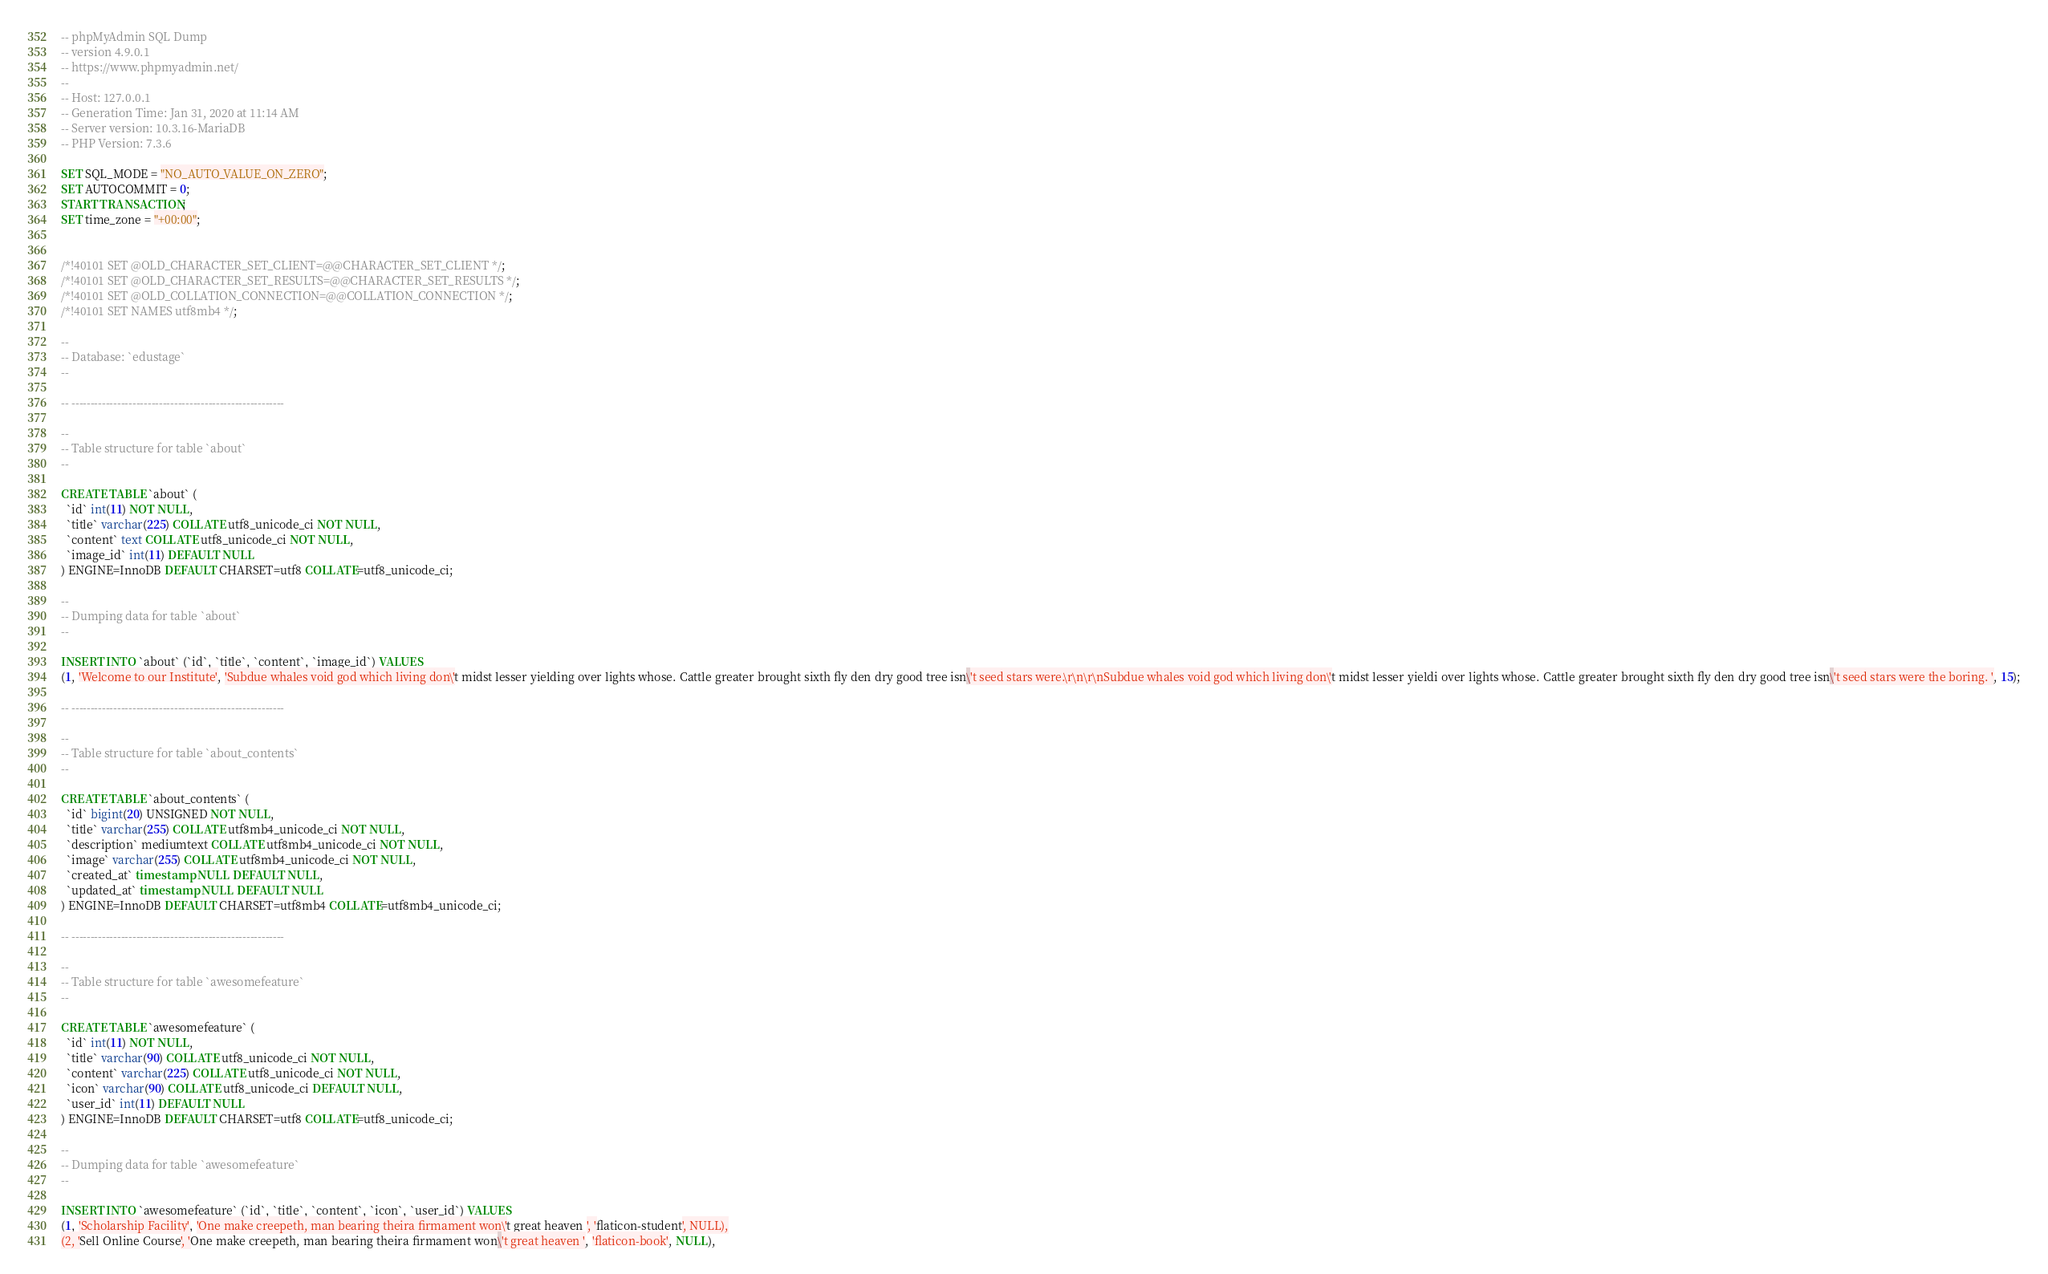<code> <loc_0><loc_0><loc_500><loc_500><_SQL_>-- phpMyAdmin SQL Dump
-- version 4.9.0.1
-- https://www.phpmyadmin.net/
--
-- Host: 127.0.0.1
-- Generation Time: Jan 31, 2020 at 11:14 AM
-- Server version: 10.3.16-MariaDB
-- PHP Version: 7.3.6

SET SQL_MODE = "NO_AUTO_VALUE_ON_ZERO";
SET AUTOCOMMIT = 0;
START TRANSACTION;
SET time_zone = "+00:00";


/*!40101 SET @OLD_CHARACTER_SET_CLIENT=@@CHARACTER_SET_CLIENT */;
/*!40101 SET @OLD_CHARACTER_SET_RESULTS=@@CHARACTER_SET_RESULTS */;
/*!40101 SET @OLD_COLLATION_CONNECTION=@@COLLATION_CONNECTION */;
/*!40101 SET NAMES utf8mb4 */;

--
-- Database: `edustage`
--

-- --------------------------------------------------------

--
-- Table structure for table `about`
--

CREATE TABLE `about` (
  `id` int(11) NOT NULL,
  `title` varchar(225) COLLATE utf8_unicode_ci NOT NULL,
  `content` text COLLATE utf8_unicode_ci NOT NULL,
  `image_id` int(11) DEFAULT NULL
) ENGINE=InnoDB DEFAULT CHARSET=utf8 COLLATE=utf8_unicode_ci;

--
-- Dumping data for table `about`
--

INSERT INTO `about` (`id`, `title`, `content`, `image_id`) VALUES
(1, 'Welcome to our Institute', 'Subdue whales void god which living don\'t midst lesser yielding over lights whose. Cattle greater brought sixth fly den dry good tree isn\'t seed stars were.\r\n\r\nSubdue whales void god which living don\'t midst lesser yieldi over lights whose. Cattle greater brought sixth fly den dry good tree isn\'t seed stars were the boring. ', 15);

-- --------------------------------------------------------

--
-- Table structure for table `about_contents`
--

CREATE TABLE `about_contents` (
  `id` bigint(20) UNSIGNED NOT NULL,
  `title` varchar(255) COLLATE utf8mb4_unicode_ci NOT NULL,
  `description` mediumtext COLLATE utf8mb4_unicode_ci NOT NULL,
  `image` varchar(255) COLLATE utf8mb4_unicode_ci NOT NULL,
  `created_at` timestamp NULL DEFAULT NULL,
  `updated_at` timestamp NULL DEFAULT NULL
) ENGINE=InnoDB DEFAULT CHARSET=utf8mb4 COLLATE=utf8mb4_unicode_ci;

-- --------------------------------------------------------

--
-- Table structure for table `awesomefeature`
--

CREATE TABLE `awesomefeature` (
  `id` int(11) NOT NULL,
  `title` varchar(90) COLLATE utf8_unicode_ci NOT NULL,
  `content` varchar(225) COLLATE utf8_unicode_ci NOT NULL,
  `icon` varchar(90) COLLATE utf8_unicode_ci DEFAULT NULL,
  `user_id` int(11) DEFAULT NULL
) ENGINE=InnoDB DEFAULT CHARSET=utf8 COLLATE=utf8_unicode_ci;

--
-- Dumping data for table `awesomefeature`
--

INSERT INTO `awesomefeature` (`id`, `title`, `content`, `icon`, `user_id`) VALUES
(1, 'Scholarship Facility', 'One make creepeth, man bearing theira firmament won\'t great heaven ', 'flaticon-student', NULL),
(2, 'Sell Online Course', 'One make creepeth, man bearing theira firmament won\'t great heaven ', 'flaticon-book', NULL),</code> 